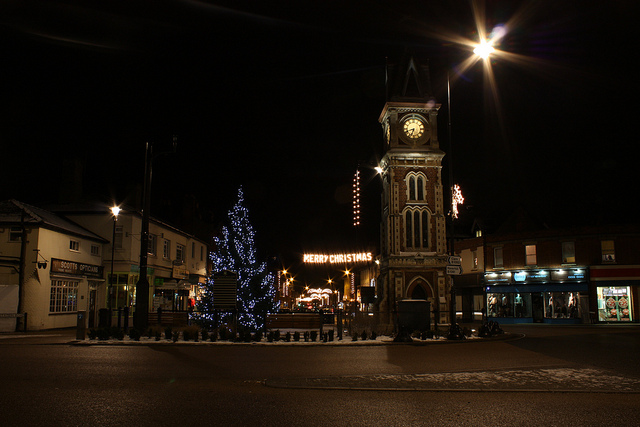<image>What is the name of the building? I don't know the name of the building. It could be a clock tower or Big Ben. What is the meaning of the white traffic sign? It is ambiguous what the white traffic sign means. There may not even be a traffic sign in the image. What is the name of the building? The name of the building is unclear. It can be referred to as 'clock tower', 'big ben' or 'city building'. What is the meaning of the white traffic sign? The meaning of the white traffic sign is unknown. It can be 'stop', 'light', 'direction', 'visibility', or 'information'. 